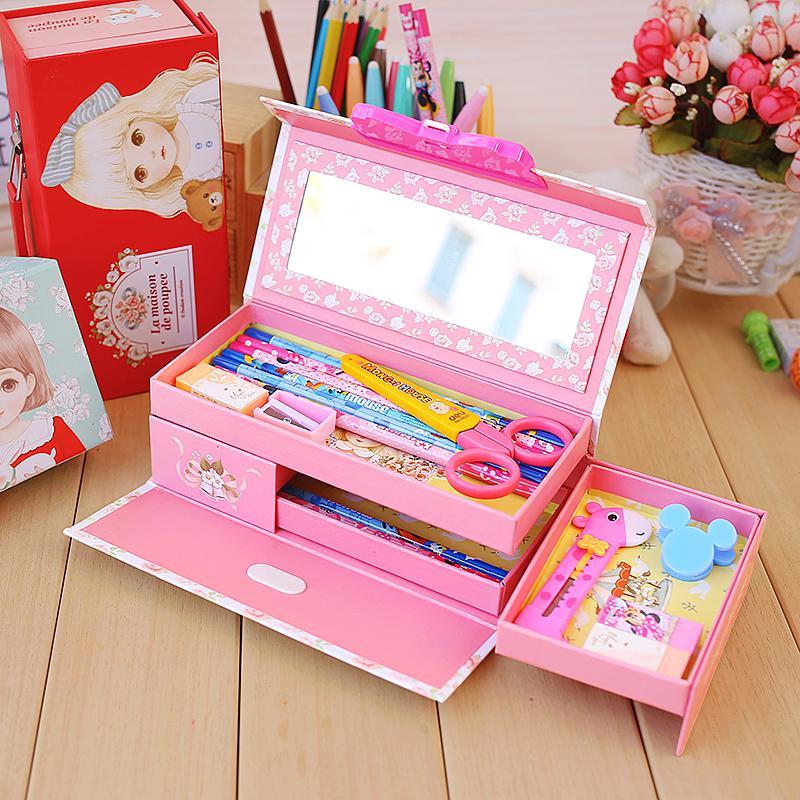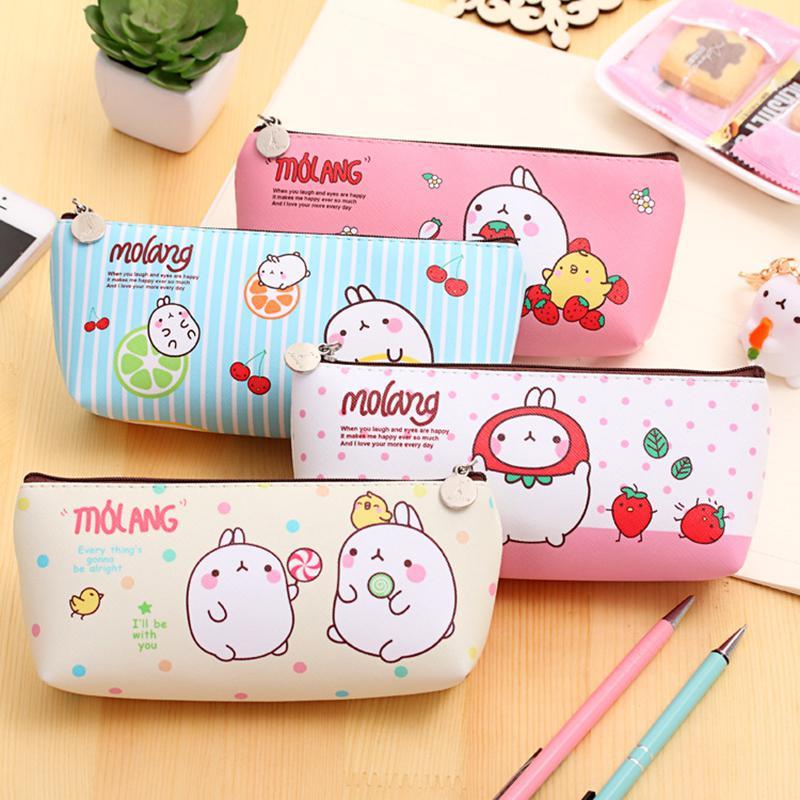The first image is the image on the left, the second image is the image on the right. Examine the images to the left and right. Is the description "One image shows a filled box-shaped pink pencil case with a flip-up lid, and the other image shows several versions of closed cases with cartoon creatures on the fronts." accurate? Answer yes or no. Yes. The first image is the image on the left, the second image is the image on the right. For the images displayed, is the sentence "One of the images has a container of flowers in the background." factually correct? Answer yes or no. Yes. 